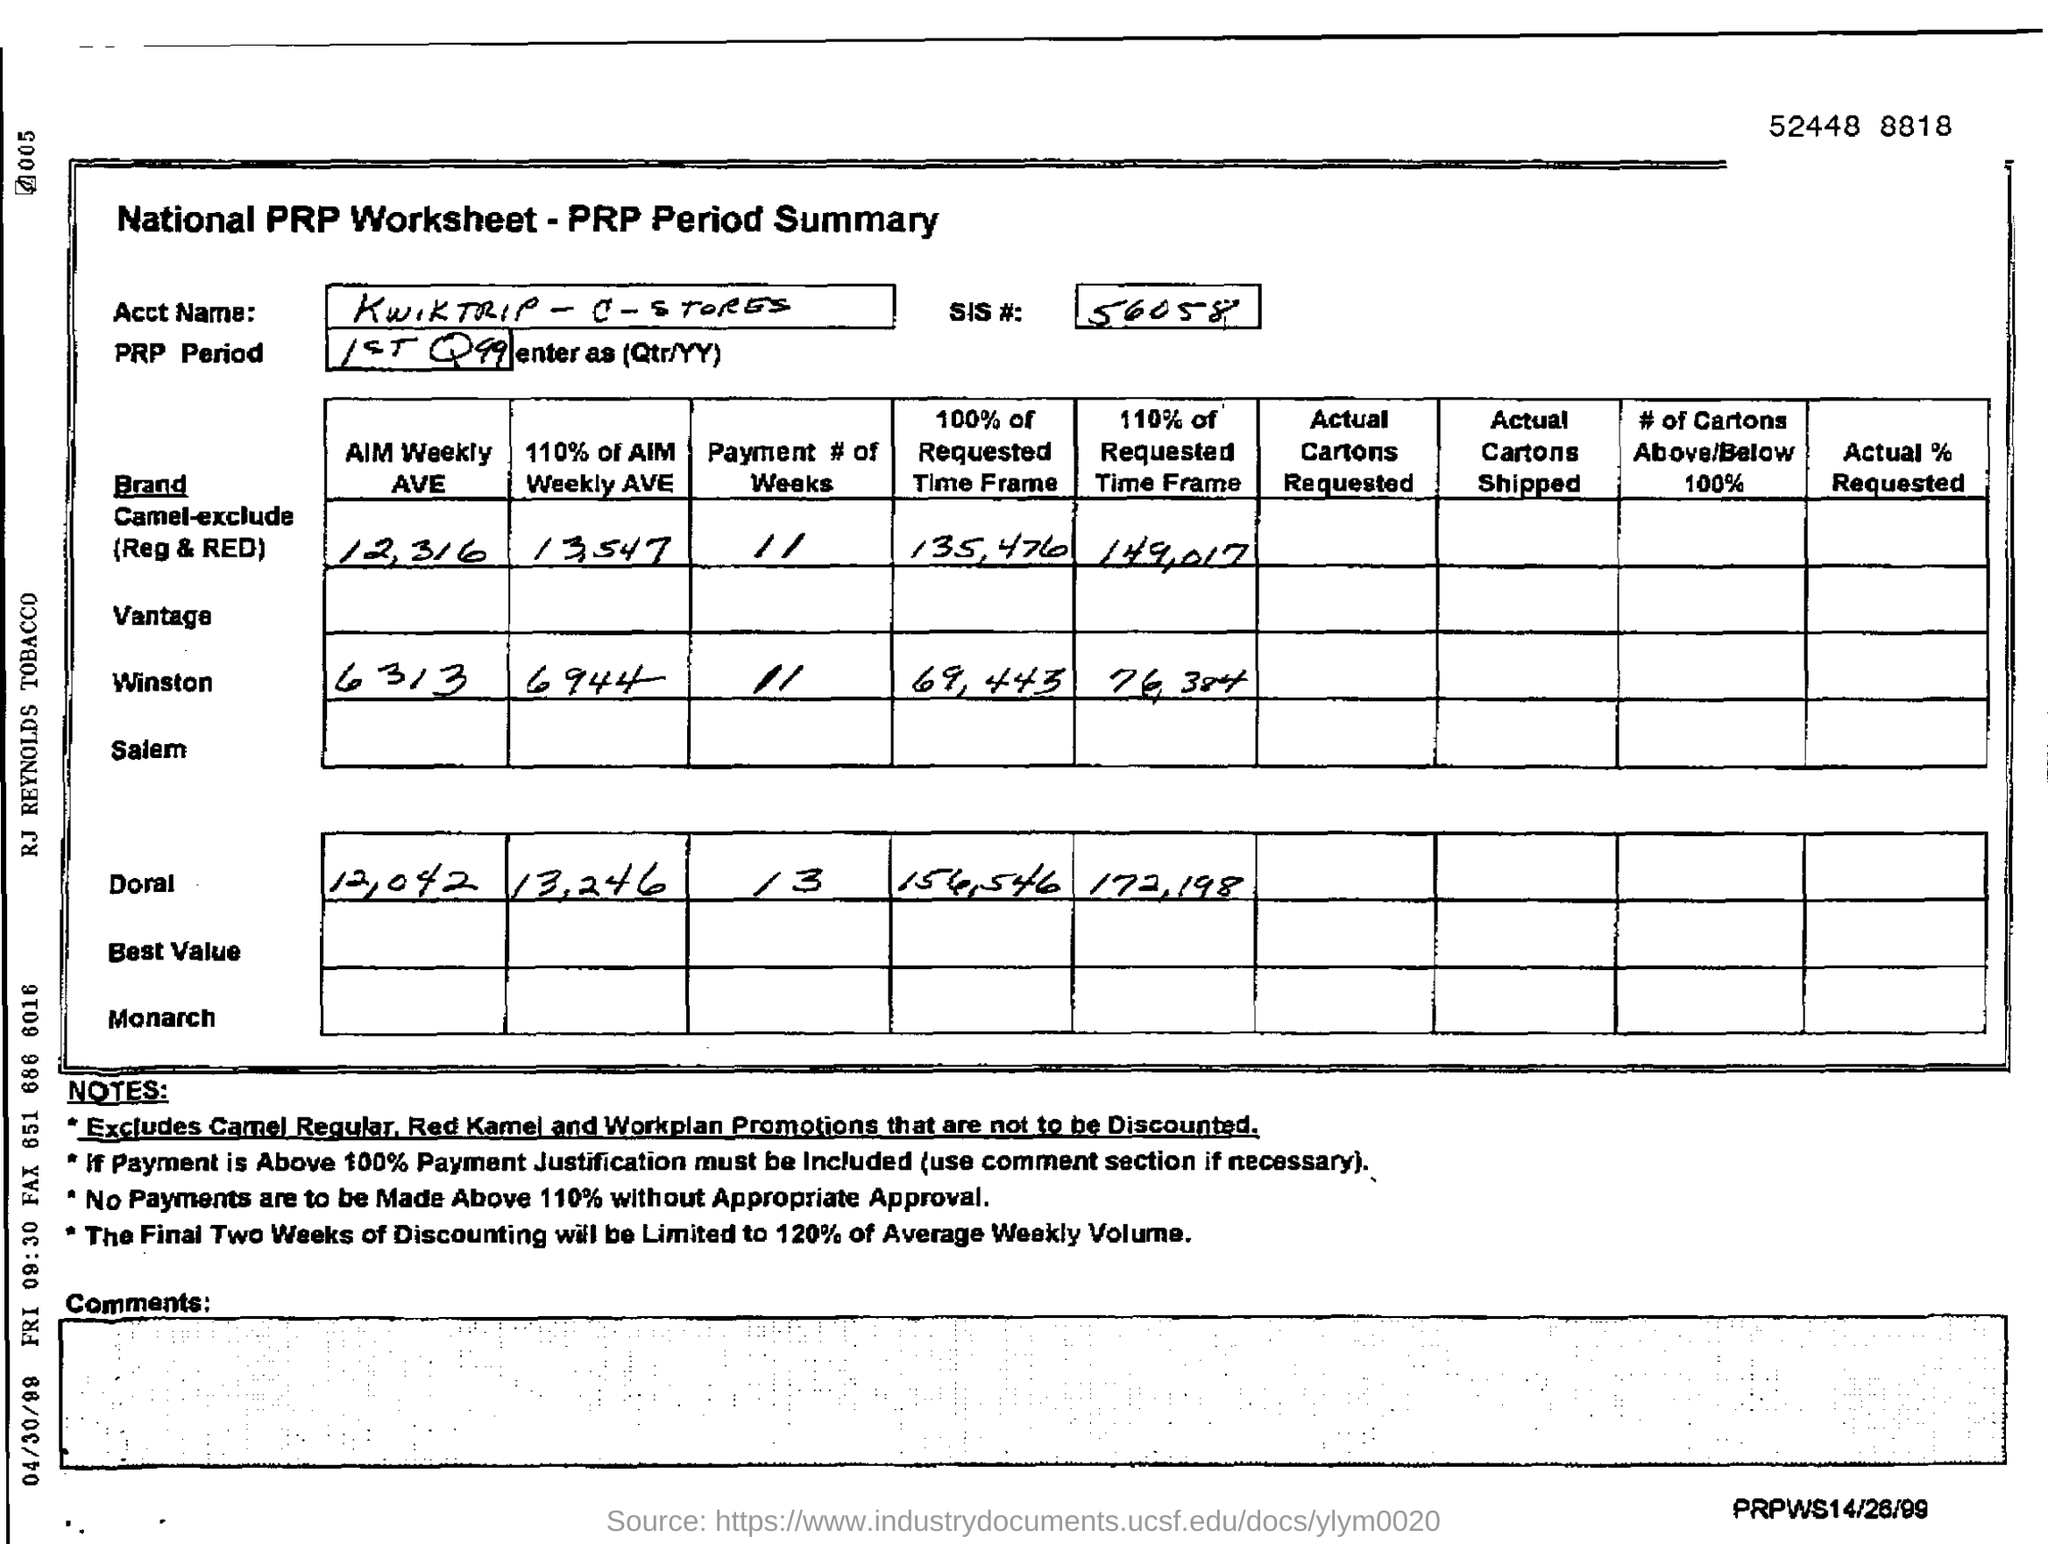What is the SIS# mentioned in the form?
Your answer should be very brief. 56058. What is the digit shown at the top right corner?
Offer a terse response. 52448 8818. 